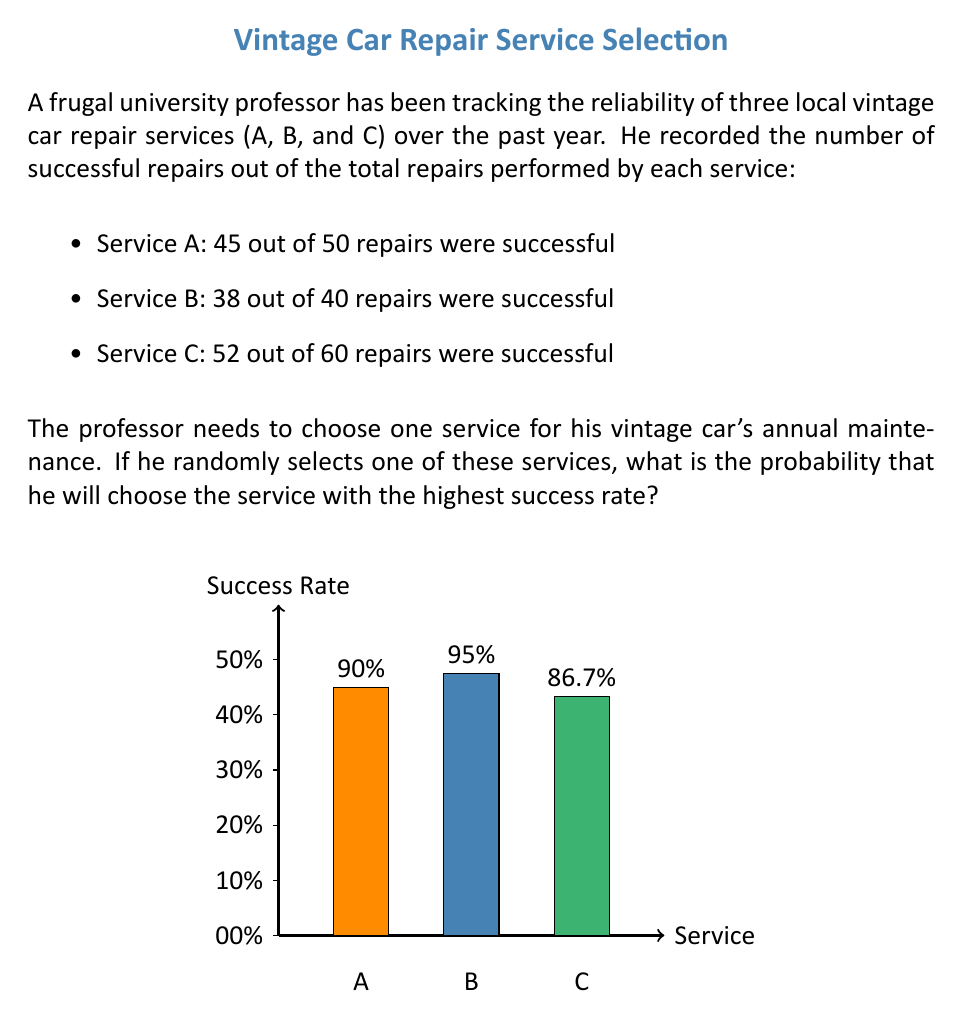Can you answer this question? To solve this problem, we need to follow these steps:

1. Calculate the success rate for each service:
   Service A: $\frac{45}{50} = 0.90$ or 90%
   Service B: $\frac{38}{40} = 0.95$ or 95%
   Service C: $\frac{52}{60} = \frac{26}{30} \approx 0.867$ or 86.7%

2. Identify the service with the highest success rate:
   Service B has the highest success rate at 95%.

3. Calculate the probability of randomly selecting Service B:
   Since there are three services to choose from, and we assume each service has an equal chance of being selected, the probability of choosing any one service is $\frac{1}{3}$.

Therefore, the probability of randomly selecting the service with the highest success rate (Service B) is $\frac{1}{3}$.

This problem demonstrates the application of basic probability concepts in analyzing the reliability of different car repair services, which is relevant to the professor's need for trustworthy maintenance for his vintage car.
Answer: $\frac{1}{3}$ 